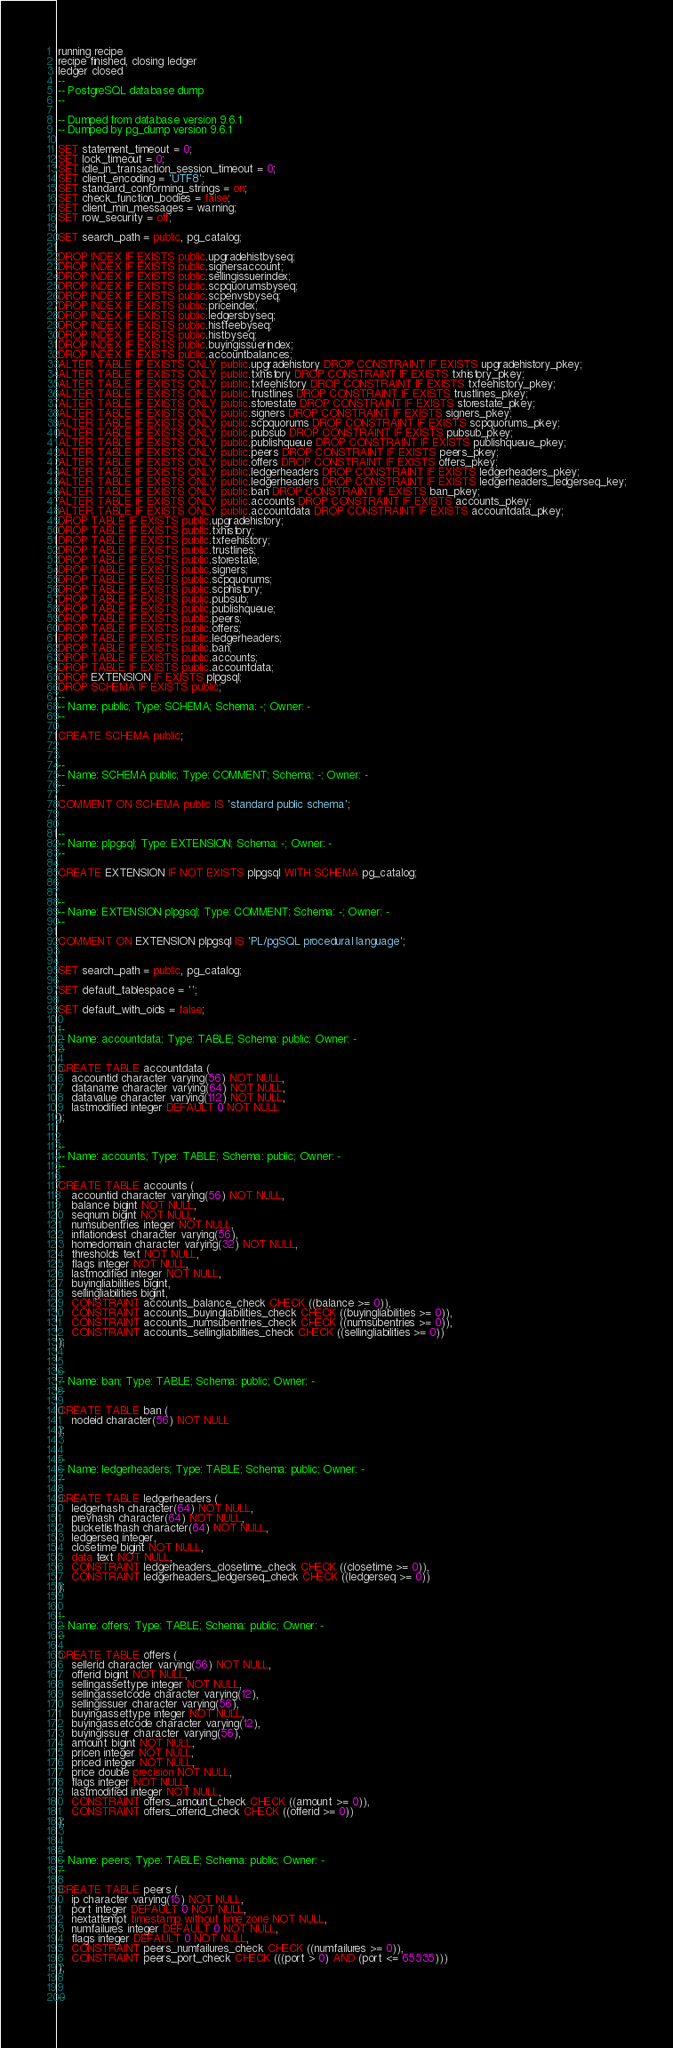Convert code to text. <code><loc_0><loc_0><loc_500><loc_500><_SQL_>running recipe
recipe finished, closing ledger
ledger closed
--
-- PostgreSQL database dump
--

-- Dumped from database version 9.6.1
-- Dumped by pg_dump version 9.6.1

SET statement_timeout = 0;
SET lock_timeout = 0;
SET idle_in_transaction_session_timeout = 0;
SET client_encoding = 'UTF8';
SET standard_conforming_strings = on;
SET check_function_bodies = false;
SET client_min_messages = warning;
SET row_security = off;

SET search_path = public, pg_catalog;

DROP INDEX IF EXISTS public.upgradehistbyseq;
DROP INDEX IF EXISTS public.signersaccount;
DROP INDEX IF EXISTS public.sellingissuerindex;
DROP INDEX IF EXISTS public.scpquorumsbyseq;
DROP INDEX IF EXISTS public.scpenvsbyseq;
DROP INDEX IF EXISTS public.priceindex;
DROP INDEX IF EXISTS public.ledgersbyseq;
DROP INDEX IF EXISTS public.histfeebyseq;
DROP INDEX IF EXISTS public.histbyseq;
DROP INDEX IF EXISTS public.buyingissuerindex;
DROP INDEX IF EXISTS public.accountbalances;
ALTER TABLE IF EXISTS ONLY public.upgradehistory DROP CONSTRAINT IF EXISTS upgradehistory_pkey;
ALTER TABLE IF EXISTS ONLY public.txhistory DROP CONSTRAINT IF EXISTS txhistory_pkey;
ALTER TABLE IF EXISTS ONLY public.txfeehistory DROP CONSTRAINT IF EXISTS txfeehistory_pkey;
ALTER TABLE IF EXISTS ONLY public.trustlines DROP CONSTRAINT IF EXISTS trustlines_pkey;
ALTER TABLE IF EXISTS ONLY public.storestate DROP CONSTRAINT IF EXISTS storestate_pkey;
ALTER TABLE IF EXISTS ONLY public.signers DROP CONSTRAINT IF EXISTS signers_pkey;
ALTER TABLE IF EXISTS ONLY public.scpquorums DROP CONSTRAINT IF EXISTS scpquorums_pkey;
ALTER TABLE IF EXISTS ONLY public.pubsub DROP CONSTRAINT IF EXISTS pubsub_pkey;
ALTER TABLE IF EXISTS ONLY public.publishqueue DROP CONSTRAINT IF EXISTS publishqueue_pkey;
ALTER TABLE IF EXISTS ONLY public.peers DROP CONSTRAINT IF EXISTS peers_pkey;
ALTER TABLE IF EXISTS ONLY public.offers DROP CONSTRAINT IF EXISTS offers_pkey;
ALTER TABLE IF EXISTS ONLY public.ledgerheaders DROP CONSTRAINT IF EXISTS ledgerheaders_pkey;
ALTER TABLE IF EXISTS ONLY public.ledgerheaders DROP CONSTRAINT IF EXISTS ledgerheaders_ledgerseq_key;
ALTER TABLE IF EXISTS ONLY public.ban DROP CONSTRAINT IF EXISTS ban_pkey;
ALTER TABLE IF EXISTS ONLY public.accounts DROP CONSTRAINT IF EXISTS accounts_pkey;
ALTER TABLE IF EXISTS ONLY public.accountdata DROP CONSTRAINT IF EXISTS accountdata_pkey;
DROP TABLE IF EXISTS public.upgradehistory;
DROP TABLE IF EXISTS public.txhistory;
DROP TABLE IF EXISTS public.txfeehistory;
DROP TABLE IF EXISTS public.trustlines;
DROP TABLE IF EXISTS public.storestate;
DROP TABLE IF EXISTS public.signers;
DROP TABLE IF EXISTS public.scpquorums;
DROP TABLE IF EXISTS public.scphistory;
DROP TABLE IF EXISTS public.pubsub;
DROP TABLE IF EXISTS public.publishqueue;
DROP TABLE IF EXISTS public.peers;
DROP TABLE IF EXISTS public.offers;
DROP TABLE IF EXISTS public.ledgerheaders;
DROP TABLE IF EXISTS public.ban;
DROP TABLE IF EXISTS public.accounts;
DROP TABLE IF EXISTS public.accountdata;
DROP EXTENSION IF EXISTS plpgsql;
DROP SCHEMA IF EXISTS public;
--
-- Name: public; Type: SCHEMA; Schema: -; Owner: -
--

CREATE SCHEMA public;


--
-- Name: SCHEMA public; Type: COMMENT; Schema: -; Owner: -
--

COMMENT ON SCHEMA public IS 'standard public schema';


--
-- Name: plpgsql; Type: EXTENSION; Schema: -; Owner: -
--

CREATE EXTENSION IF NOT EXISTS plpgsql WITH SCHEMA pg_catalog;


--
-- Name: EXTENSION plpgsql; Type: COMMENT; Schema: -; Owner: -
--

COMMENT ON EXTENSION plpgsql IS 'PL/pgSQL procedural language';


SET search_path = public, pg_catalog;

SET default_tablespace = '';

SET default_with_oids = false;

--
-- Name: accountdata; Type: TABLE; Schema: public; Owner: -
--

CREATE TABLE accountdata (
    accountid character varying(56) NOT NULL,
    dataname character varying(64) NOT NULL,
    datavalue character varying(112) NOT NULL,
    lastmodified integer DEFAULT 0 NOT NULL
);


--
-- Name: accounts; Type: TABLE; Schema: public; Owner: -
--

CREATE TABLE accounts (
    accountid character varying(56) NOT NULL,
    balance bigint NOT NULL,
    seqnum bigint NOT NULL,
    numsubentries integer NOT NULL,
    inflationdest character varying(56),
    homedomain character varying(32) NOT NULL,
    thresholds text NOT NULL,
    flags integer NOT NULL,
    lastmodified integer NOT NULL,
    buyingliabilities bigint,
    sellingliabilities bigint,
    CONSTRAINT accounts_balance_check CHECK ((balance >= 0)),
    CONSTRAINT accounts_buyingliabilities_check CHECK ((buyingliabilities >= 0)),
    CONSTRAINT accounts_numsubentries_check CHECK ((numsubentries >= 0)),
    CONSTRAINT accounts_sellingliabilities_check CHECK ((sellingliabilities >= 0))
);


--
-- Name: ban; Type: TABLE; Schema: public; Owner: -
--

CREATE TABLE ban (
    nodeid character(56) NOT NULL
);


--
-- Name: ledgerheaders; Type: TABLE; Schema: public; Owner: -
--

CREATE TABLE ledgerheaders (
    ledgerhash character(64) NOT NULL,
    prevhash character(64) NOT NULL,
    bucketlisthash character(64) NOT NULL,
    ledgerseq integer,
    closetime bigint NOT NULL,
    data text NOT NULL,
    CONSTRAINT ledgerheaders_closetime_check CHECK ((closetime >= 0)),
    CONSTRAINT ledgerheaders_ledgerseq_check CHECK ((ledgerseq >= 0))
);


--
-- Name: offers; Type: TABLE; Schema: public; Owner: -
--

CREATE TABLE offers (
    sellerid character varying(56) NOT NULL,
    offerid bigint NOT NULL,
    sellingassettype integer NOT NULL,
    sellingassetcode character varying(12),
    sellingissuer character varying(56),
    buyingassettype integer NOT NULL,
    buyingassetcode character varying(12),
    buyingissuer character varying(56),
    amount bigint NOT NULL,
    pricen integer NOT NULL,
    priced integer NOT NULL,
    price double precision NOT NULL,
    flags integer NOT NULL,
    lastmodified integer NOT NULL,
    CONSTRAINT offers_amount_check CHECK ((amount >= 0)),
    CONSTRAINT offers_offerid_check CHECK ((offerid >= 0))
);


--
-- Name: peers; Type: TABLE; Schema: public; Owner: -
--

CREATE TABLE peers (
    ip character varying(15) NOT NULL,
    port integer DEFAULT 0 NOT NULL,
    nextattempt timestamp without time zone NOT NULL,
    numfailures integer DEFAULT 0 NOT NULL,
    flags integer DEFAULT 0 NOT NULL,
    CONSTRAINT peers_numfailures_check CHECK ((numfailures >= 0)),
    CONSTRAINT peers_port_check CHECK (((port > 0) AND (port <= 65535)))
);


--</code> 